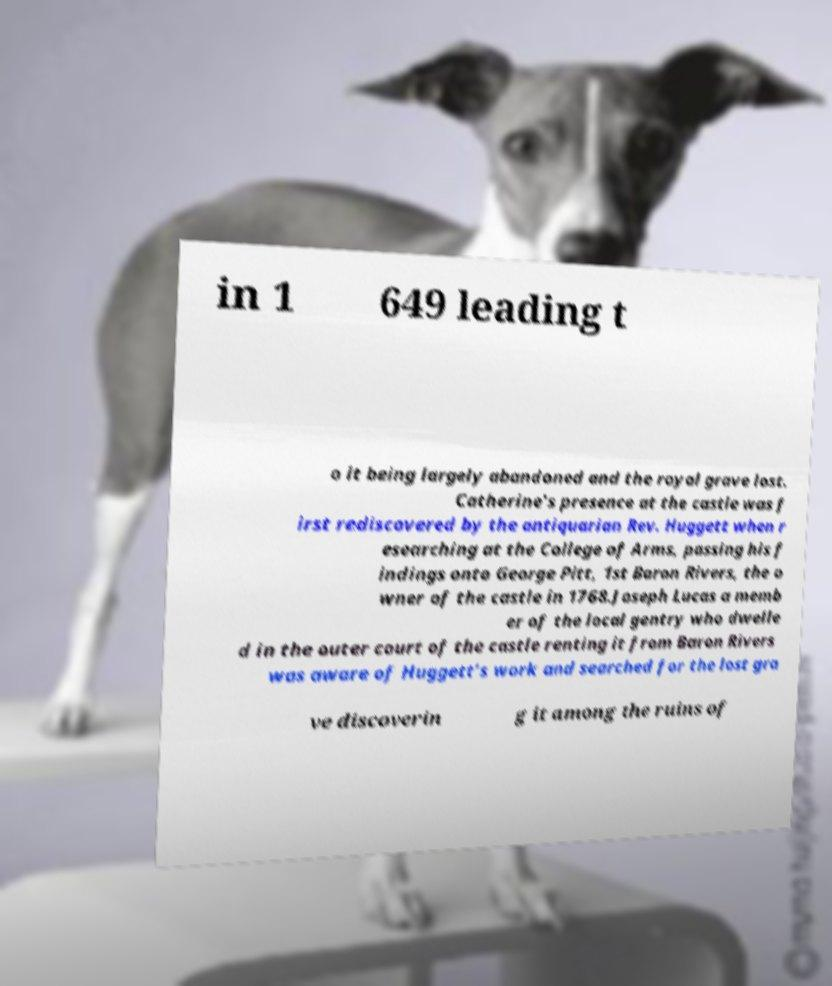There's text embedded in this image that I need extracted. Can you transcribe it verbatim? in 1 649 leading t o it being largely abandoned and the royal grave lost. Catherine’s presence at the castle was f irst rediscovered by the antiquarian Rev. Huggett when r esearching at the College of Arms, passing his f indings onto George Pitt, 1st Baron Rivers, the o wner of the castle in 1768.Joseph Lucas a memb er of the local gentry who dwelle d in the outer court of the castle renting it from Baron Rivers was aware of Huggett’s work and searched for the lost gra ve discoverin g it among the ruins of 